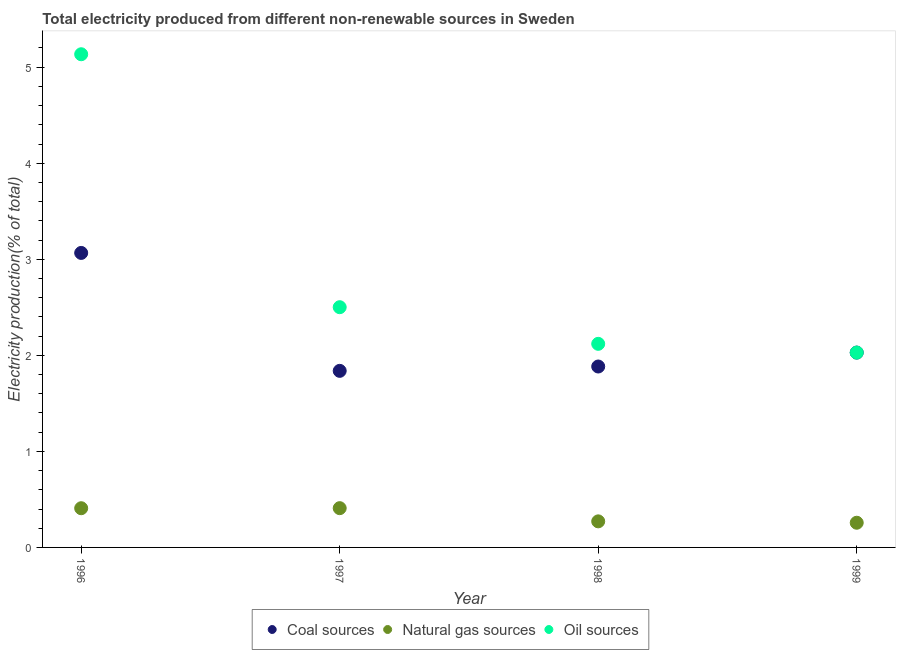How many different coloured dotlines are there?
Make the answer very short. 3. Is the number of dotlines equal to the number of legend labels?
Your answer should be very brief. Yes. What is the percentage of electricity produced by natural gas in 1996?
Provide a succinct answer. 0.41. Across all years, what is the maximum percentage of electricity produced by coal?
Your answer should be very brief. 3.07. Across all years, what is the minimum percentage of electricity produced by oil sources?
Offer a very short reply. 2.03. In which year was the percentage of electricity produced by oil sources minimum?
Offer a very short reply. 1999. What is the total percentage of electricity produced by coal in the graph?
Provide a succinct answer. 8.82. What is the difference between the percentage of electricity produced by oil sources in 1997 and that in 1998?
Ensure brevity in your answer.  0.38. What is the difference between the percentage of electricity produced by natural gas in 1997 and the percentage of electricity produced by oil sources in 1998?
Offer a very short reply. -1.71. What is the average percentage of electricity produced by coal per year?
Offer a very short reply. 2.2. In the year 1998, what is the difference between the percentage of electricity produced by oil sources and percentage of electricity produced by coal?
Provide a succinct answer. 0.24. What is the ratio of the percentage of electricity produced by coal in 1998 to that in 1999?
Offer a very short reply. 0.93. Is the difference between the percentage of electricity produced by oil sources in 1997 and 1999 greater than the difference between the percentage of electricity produced by natural gas in 1997 and 1999?
Offer a terse response. Yes. What is the difference between the highest and the second highest percentage of electricity produced by natural gas?
Your answer should be very brief. 0. What is the difference between the highest and the lowest percentage of electricity produced by natural gas?
Provide a succinct answer. 0.15. In how many years, is the percentage of electricity produced by coal greater than the average percentage of electricity produced by coal taken over all years?
Give a very brief answer. 1. Is the sum of the percentage of electricity produced by oil sources in 1996 and 1998 greater than the maximum percentage of electricity produced by natural gas across all years?
Your answer should be compact. Yes. Is it the case that in every year, the sum of the percentage of electricity produced by coal and percentage of electricity produced by natural gas is greater than the percentage of electricity produced by oil sources?
Provide a short and direct response. No. How many dotlines are there?
Provide a short and direct response. 3. What is the difference between two consecutive major ticks on the Y-axis?
Provide a succinct answer. 1. Does the graph contain any zero values?
Your response must be concise. No. Does the graph contain grids?
Your answer should be compact. No. Where does the legend appear in the graph?
Your answer should be very brief. Bottom center. How are the legend labels stacked?
Make the answer very short. Horizontal. What is the title of the graph?
Your answer should be very brief. Total electricity produced from different non-renewable sources in Sweden. What is the label or title of the X-axis?
Your answer should be very brief. Year. What is the Electricity production(% of total) in Coal sources in 1996?
Provide a succinct answer. 3.07. What is the Electricity production(% of total) in Natural gas sources in 1996?
Your response must be concise. 0.41. What is the Electricity production(% of total) in Oil sources in 1996?
Your response must be concise. 5.13. What is the Electricity production(% of total) of Coal sources in 1997?
Your answer should be compact. 1.84. What is the Electricity production(% of total) in Natural gas sources in 1997?
Offer a terse response. 0.41. What is the Electricity production(% of total) of Oil sources in 1997?
Your response must be concise. 2.5. What is the Electricity production(% of total) in Coal sources in 1998?
Your answer should be compact. 1.88. What is the Electricity production(% of total) of Natural gas sources in 1998?
Ensure brevity in your answer.  0.27. What is the Electricity production(% of total) in Oil sources in 1998?
Your answer should be compact. 2.12. What is the Electricity production(% of total) in Coal sources in 1999?
Your answer should be compact. 2.03. What is the Electricity production(% of total) of Natural gas sources in 1999?
Offer a terse response. 0.26. What is the Electricity production(% of total) in Oil sources in 1999?
Offer a very short reply. 2.03. Across all years, what is the maximum Electricity production(% of total) of Coal sources?
Your answer should be very brief. 3.07. Across all years, what is the maximum Electricity production(% of total) in Natural gas sources?
Offer a terse response. 0.41. Across all years, what is the maximum Electricity production(% of total) in Oil sources?
Your response must be concise. 5.13. Across all years, what is the minimum Electricity production(% of total) in Coal sources?
Your answer should be very brief. 1.84. Across all years, what is the minimum Electricity production(% of total) in Natural gas sources?
Provide a succinct answer. 0.26. Across all years, what is the minimum Electricity production(% of total) of Oil sources?
Your response must be concise. 2.03. What is the total Electricity production(% of total) in Coal sources in the graph?
Provide a succinct answer. 8.82. What is the total Electricity production(% of total) in Natural gas sources in the graph?
Your answer should be very brief. 1.35. What is the total Electricity production(% of total) of Oil sources in the graph?
Provide a short and direct response. 11.78. What is the difference between the Electricity production(% of total) in Coal sources in 1996 and that in 1997?
Keep it short and to the point. 1.23. What is the difference between the Electricity production(% of total) in Natural gas sources in 1996 and that in 1997?
Your answer should be very brief. -0. What is the difference between the Electricity production(% of total) in Oil sources in 1996 and that in 1997?
Ensure brevity in your answer.  2.63. What is the difference between the Electricity production(% of total) of Coal sources in 1996 and that in 1998?
Keep it short and to the point. 1.18. What is the difference between the Electricity production(% of total) of Natural gas sources in 1996 and that in 1998?
Your answer should be very brief. 0.14. What is the difference between the Electricity production(% of total) in Oil sources in 1996 and that in 1998?
Make the answer very short. 3.02. What is the difference between the Electricity production(% of total) in Coal sources in 1996 and that in 1999?
Offer a very short reply. 1.04. What is the difference between the Electricity production(% of total) in Natural gas sources in 1996 and that in 1999?
Your answer should be compact. 0.15. What is the difference between the Electricity production(% of total) of Oil sources in 1996 and that in 1999?
Keep it short and to the point. 3.11. What is the difference between the Electricity production(% of total) of Coal sources in 1997 and that in 1998?
Your response must be concise. -0.05. What is the difference between the Electricity production(% of total) in Natural gas sources in 1997 and that in 1998?
Provide a succinct answer. 0.14. What is the difference between the Electricity production(% of total) of Oil sources in 1997 and that in 1998?
Offer a very short reply. 0.38. What is the difference between the Electricity production(% of total) in Coal sources in 1997 and that in 1999?
Your response must be concise. -0.19. What is the difference between the Electricity production(% of total) in Natural gas sources in 1997 and that in 1999?
Provide a short and direct response. 0.15. What is the difference between the Electricity production(% of total) of Oil sources in 1997 and that in 1999?
Your answer should be very brief. 0.47. What is the difference between the Electricity production(% of total) in Coal sources in 1998 and that in 1999?
Your answer should be compact. -0.14. What is the difference between the Electricity production(% of total) in Natural gas sources in 1998 and that in 1999?
Offer a terse response. 0.01. What is the difference between the Electricity production(% of total) in Oil sources in 1998 and that in 1999?
Keep it short and to the point. 0.09. What is the difference between the Electricity production(% of total) of Coal sources in 1996 and the Electricity production(% of total) of Natural gas sources in 1997?
Offer a terse response. 2.66. What is the difference between the Electricity production(% of total) in Coal sources in 1996 and the Electricity production(% of total) in Oil sources in 1997?
Offer a very short reply. 0.56. What is the difference between the Electricity production(% of total) in Natural gas sources in 1996 and the Electricity production(% of total) in Oil sources in 1997?
Provide a short and direct response. -2.09. What is the difference between the Electricity production(% of total) in Coal sources in 1996 and the Electricity production(% of total) in Natural gas sources in 1998?
Your response must be concise. 2.79. What is the difference between the Electricity production(% of total) in Coal sources in 1996 and the Electricity production(% of total) in Oil sources in 1998?
Ensure brevity in your answer.  0.95. What is the difference between the Electricity production(% of total) of Natural gas sources in 1996 and the Electricity production(% of total) of Oil sources in 1998?
Offer a terse response. -1.71. What is the difference between the Electricity production(% of total) in Coal sources in 1996 and the Electricity production(% of total) in Natural gas sources in 1999?
Make the answer very short. 2.81. What is the difference between the Electricity production(% of total) of Coal sources in 1996 and the Electricity production(% of total) of Oil sources in 1999?
Your answer should be compact. 1.04. What is the difference between the Electricity production(% of total) of Natural gas sources in 1996 and the Electricity production(% of total) of Oil sources in 1999?
Ensure brevity in your answer.  -1.62. What is the difference between the Electricity production(% of total) of Coal sources in 1997 and the Electricity production(% of total) of Natural gas sources in 1998?
Keep it short and to the point. 1.57. What is the difference between the Electricity production(% of total) in Coal sources in 1997 and the Electricity production(% of total) in Oil sources in 1998?
Your answer should be very brief. -0.28. What is the difference between the Electricity production(% of total) of Natural gas sources in 1997 and the Electricity production(% of total) of Oil sources in 1998?
Ensure brevity in your answer.  -1.71. What is the difference between the Electricity production(% of total) of Coal sources in 1997 and the Electricity production(% of total) of Natural gas sources in 1999?
Give a very brief answer. 1.58. What is the difference between the Electricity production(% of total) in Coal sources in 1997 and the Electricity production(% of total) in Oil sources in 1999?
Your answer should be compact. -0.19. What is the difference between the Electricity production(% of total) of Natural gas sources in 1997 and the Electricity production(% of total) of Oil sources in 1999?
Offer a terse response. -1.62. What is the difference between the Electricity production(% of total) in Coal sources in 1998 and the Electricity production(% of total) in Natural gas sources in 1999?
Ensure brevity in your answer.  1.63. What is the difference between the Electricity production(% of total) of Coal sources in 1998 and the Electricity production(% of total) of Oil sources in 1999?
Give a very brief answer. -0.14. What is the difference between the Electricity production(% of total) of Natural gas sources in 1998 and the Electricity production(% of total) of Oil sources in 1999?
Your response must be concise. -1.76. What is the average Electricity production(% of total) of Coal sources per year?
Offer a terse response. 2.2. What is the average Electricity production(% of total) of Natural gas sources per year?
Keep it short and to the point. 0.34. What is the average Electricity production(% of total) in Oil sources per year?
Your response must be concise. 2.95. In the year 1996, what is the difference between the Electricity production(% of total) in Coal sources and Electricity production(% of total) in Natural gas sources?
Your answer should be very brief. 2.66. In the year 1996, what is the difference between the Electricity production(% of total) of Coal sources and Electricity production(% of total) of Oil sources?
Provide a short and direct response. -2.07. In the year 1996, what is the difference between the Electricity production(% of total) of Natural gas sources and Electricity production(% of total) of Oil sources?
Your response must be concise. -4.73. In the year 1997, what is the difference between the Electricity production(% of total) of Coal sources and Electricity production(% of total) of Natural gas sources?
Your answer should be very brief. 1.43. In the year 1997, what is the difference between the Electricity production(% of total) in Coal sources and Electricity production(% of total) in Oil sources?
Offer a very short reply. -0.66. In the year 1997, what is the difference between the Electricity production(% of total) in Natural gas sources and Electricity production(% of total) in Oil sources?
Your answer should be very brief. -2.09. In the year 1998, what is the difference between the Electricity production(% of total) in Coal sources and Electricity production(% of total) in Natural gas sources?
Give a very brief answer. 1.61. In the year 1998, what is the difference between the Electricity production(% of total) in Coal sources and Electricity production(% of total) in Oil sources?
Keep it short and to the point. -0.24. In the year 1998, what is the difference between the Electricity production(% of total) in Natural gas sources and Electricity production(% of total) in Oil sources?
Provide a short and direct response. -1.85. In the year 1999, what is the difference between the Electricity production(% of total) in Coal sources and Electricity production(% of total) in Natural gas sources?
Your response must be concise. 1.77. In the year 1999, what is the difference between the Electricity production(% of total) in Natural gas sources and Electricity production(% of total) in Oil sources?
Your answer should be compact. -1.77. What is the ratio of the Electricity production(% of total) in Coal sources in 1996 to that in 1997?
Give a very brief answer. 1.67. What is the ratio of the Electricity production(% of total) of Oil sources in 1996 to that in 1997?
Your answer should be compact. 2.05. What is the ratio of the Electricity production(% of total) in Coal sources in 1996 to that in 1998?
Ensure brevity in your answer.  1.63. What is the ratio of the Electricity production(% of total) in Natural gas sources in 1996 to that in 1998?
Make the answer very short. 1.5. What is the ratio of the Electricity production(% of total) of Oil sources in 1996 to that in 1998?
Offer a terse response. 2.42. What is the ratio of the Electricity production(% of total) of Coal sources in 1996 to that in 1999?
Offer a terse response. 1.51. What is the ratio of the Electricity production(% of total) in Natural gas sources in 1996 to that in 1999?
Provide a succinct answer. 1.59. What is the ratio of the Electricity production(% of total) of Oil sources in 1996 to that in 1999?
Provide a succinct answer. 2.53. What is the ratio of the Electricity production(% of total) in Natural gas sources in 1997 to that in 1998?
Your answer should be very brief. 1.51. What is the ratio of the Electricity production(% of total) in Oil sources in 1997 to that in 1998?
Provide a short and direct response. 1.18. What is the ratio of the Electricity production(% of total) of Coal sources in 1997 to that in 1999?
Offer a terse response. 0.91. What is the ratio of the Electricity production(% of total) of Natural gas sources in 1997 to that in 1999?
Your answer should be compact. 1.59. What is the ratio of the Electricity production(% of total) in Oil sources in 1997 to that in 1999?
Offer a very short reply. 1.23. What is the ratio of the Electricity production(% of total) in Coal sources in 1998 to that in 1999?
Provide a short and direct response. 0.93. What is the ratio of the Electricity production(% of total) in Natural gas sources in 1998 to that in 1999?
Your response must be concise. 1.06. What is the ratio of the Electricity production(% of total) in Oil sources in 1998 to that in 1999?
Your answer should be very brief. 1.04. What is the difference between the highest and the second highest Electricity production(% of total) of Coal sources?
Offer a very short reply. 1.04. What is the difference between the highest and the second highest Electricity production(% of total) of Natural gas sources?
Provide a short and direct response. 0. What is the difference between the highest and the second highest Electricity production(% of total) of Oil sources?
Keep it short and to the point. 2.63. What is the difference between the highest and the lowest Electricity production(% of total) in Coal sources?
Offer a very short reply. 1.23. What is the difference between the highest and the lowest Electricity production(% of total) in Natural gas sources?
Ensure brevity in your answer.  0.15. What is the difference between the highest and the lowest Electricity production(% of total) in Oil sources?
Provide a succinct answer. 3.11. 